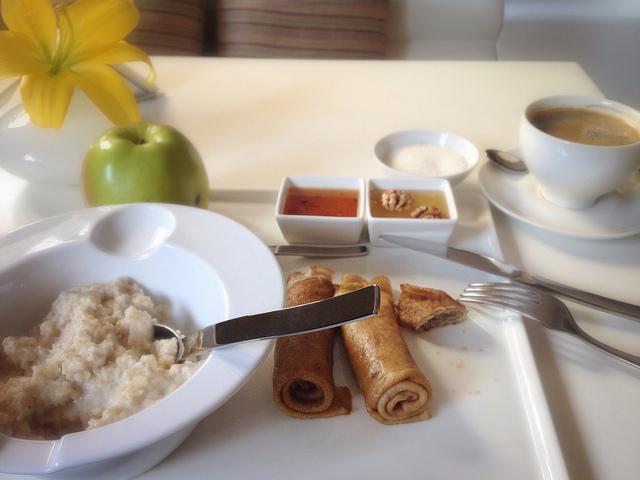Are there any eggs on the plate?
Give a very brief answer. No. What is on the spoon?
Give a very brief answer. Oatmeal. What type of utensil is in the bowl?
Concise answer only. Spoon. What is floating in the dipping sauce?
Keep it brief. Pecans. Where would the green fruit grow?
Quick response, please. Tree. 